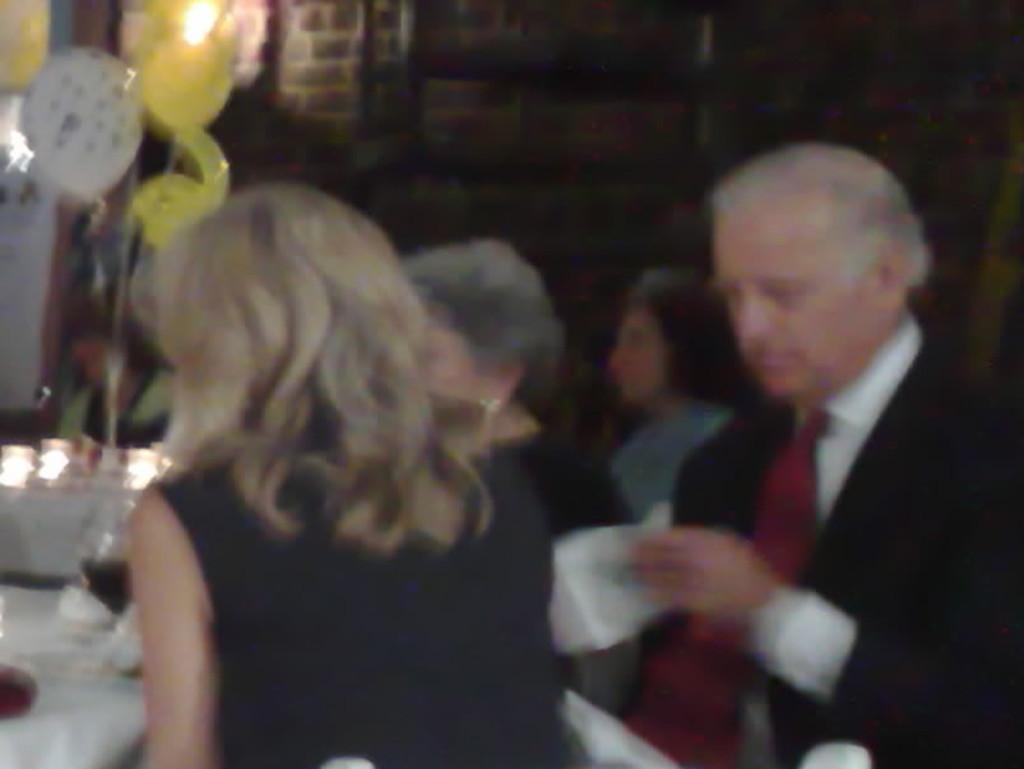Could you give a brief overview of what you see in this image? In this picture there are group of people sitting. On the left side of the image there are objects on the table and there is a balloon and there is a light on the wall. On the right side of the image there is a man sitting and holding the paper. 